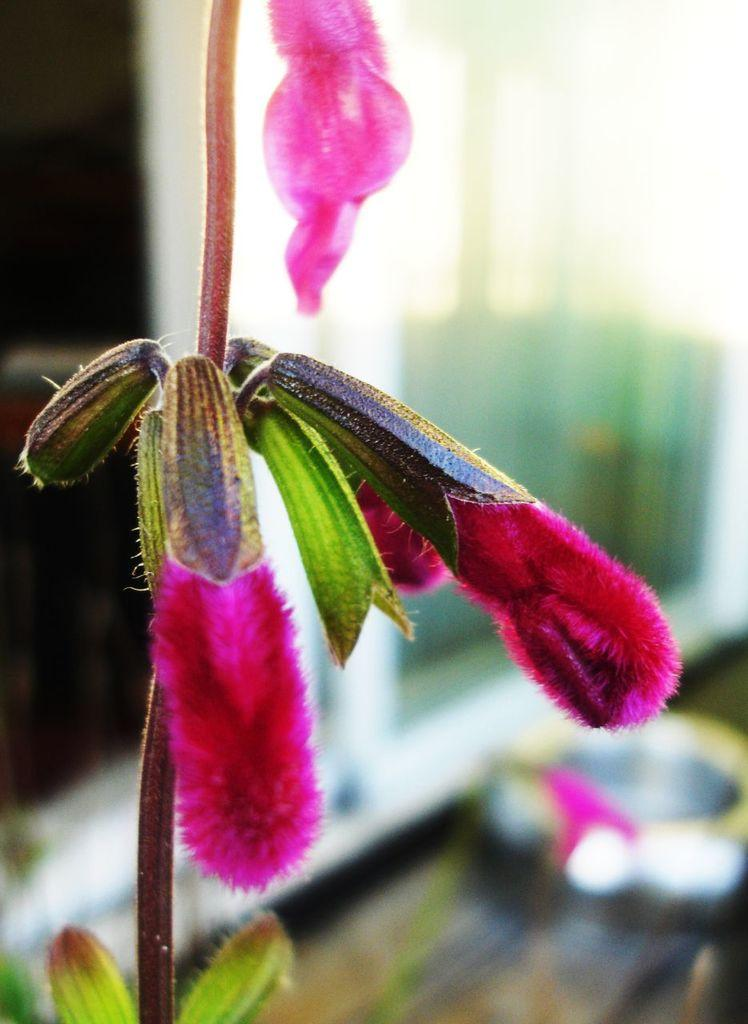What type of plant is present in the image? There is a plant with pink flowers in the image. How would you describe the background of the image? The background of the image is blurred. Can you identify any objects in the background of the image? Objects are visible in the background of the image, but their specific details are not clear due to the blurred background. What type of twig is being used for scientific experiments in the image? There is no twig or scientific experiment present in the image. What type of yoke is being used to carry objects in the image? There is no yoke or object-carrying activity depicted in the image. 